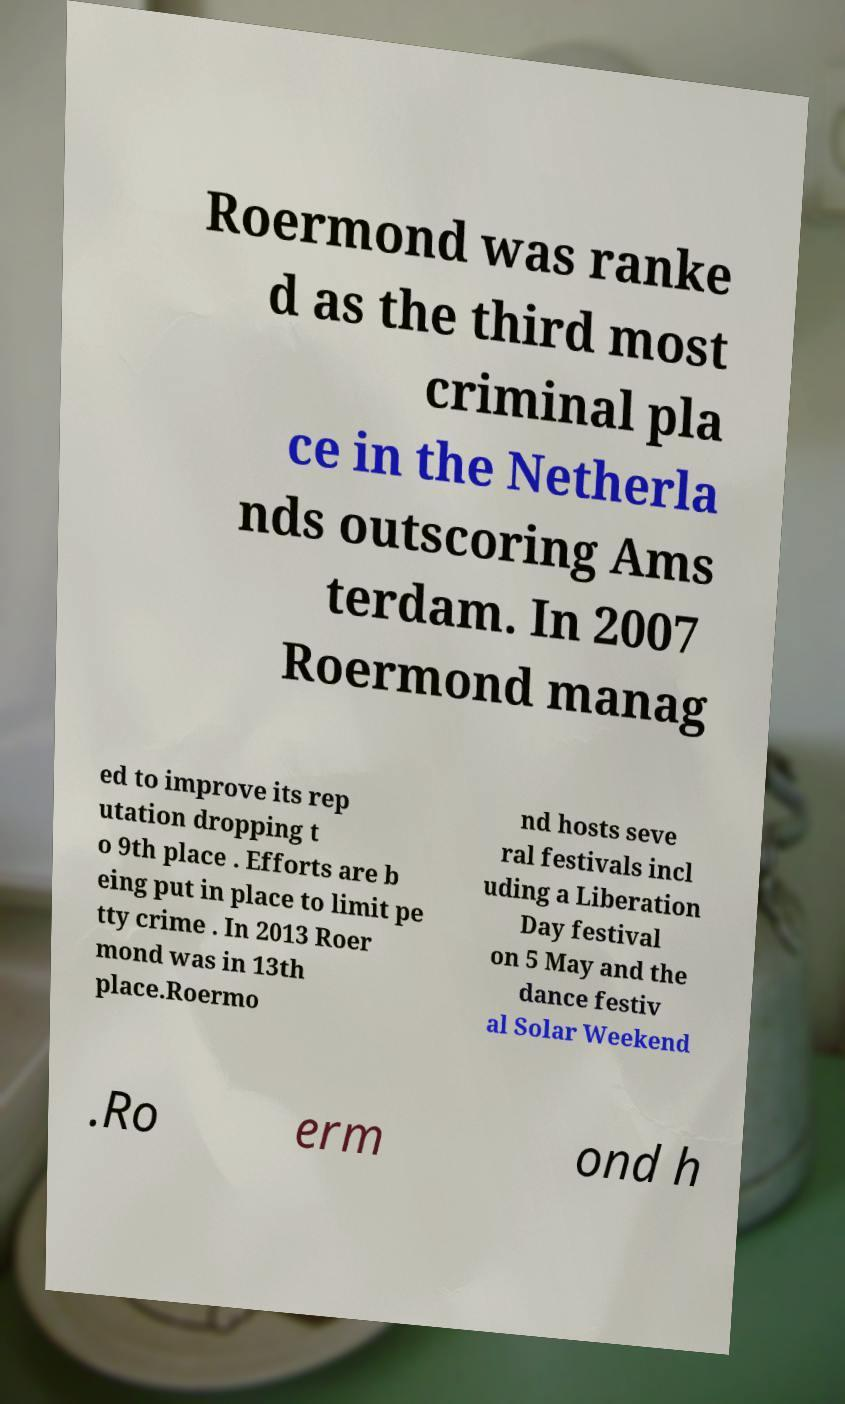Please identify and transcribe the text found in this image. Roermond was ranke d as the third most criminal pla ce in the Netherla nds outscoring Ams terdam. In 2007 Roermond manag ed to improve its rep utation dropping t o 9th place . Efforts are b eing put in place to limit pe tty crime . In 2013 Roer mond was in 13th place.Roermo nd hosts seve ral festivals incl uding a Liberation Day festival on 5 May and the dance festiv al Solar Weekend .Ro erm ond h 